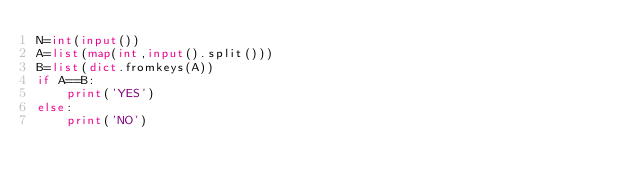Convert code to text. <code><loc_0><loc_0><loc_500><loc_500><_Python_>N=int(input())
A=list(map(int,input().split()))
B=list(dict.fromkeys(A))
if A==B:
    print('YES')
else:
    print('NO')</code> 